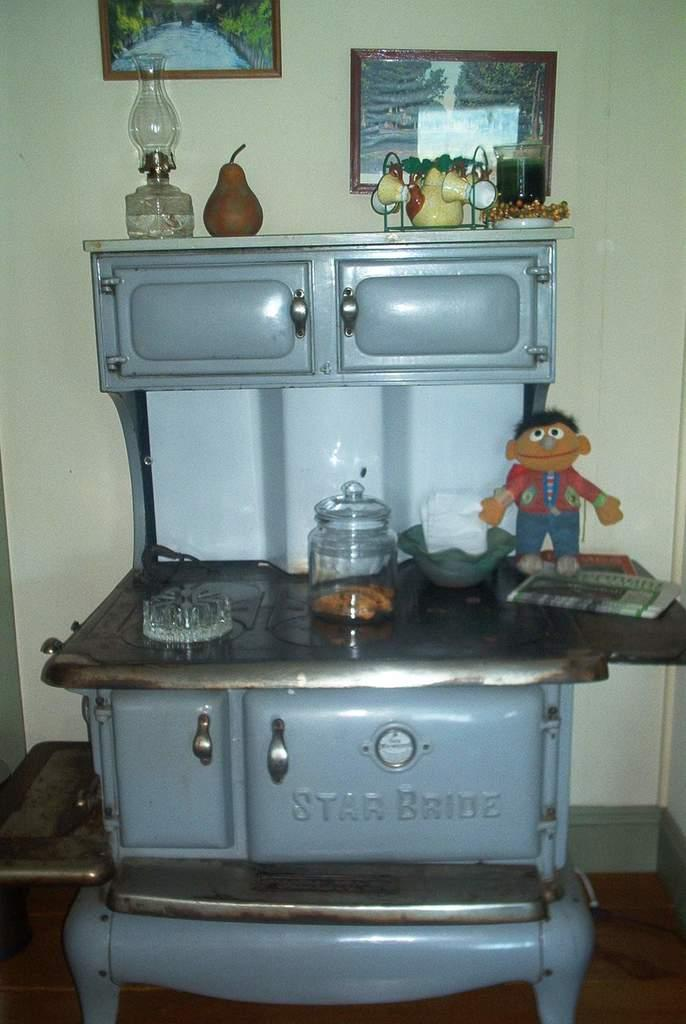<image>
Relay a brief, clear account of the picture shown. an old Star Bride stove is being used to hold many things including Ernie from Sesame street 